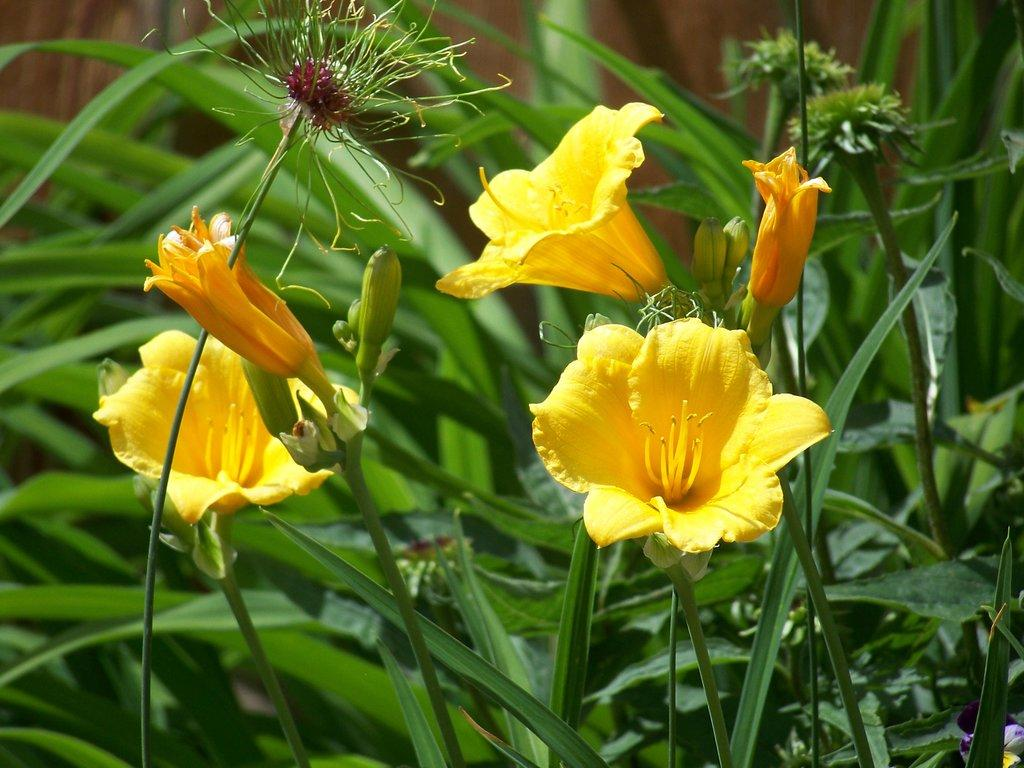What type of flora can be seen in the image? There are flowers in the image. Are there any other plants visible in the image? Yes, there are plants behind the flowers in the image. What is the chance of the flowers winning the news competition in the image? There is no news competition or any indication of a competition involving the flowers in the image. 